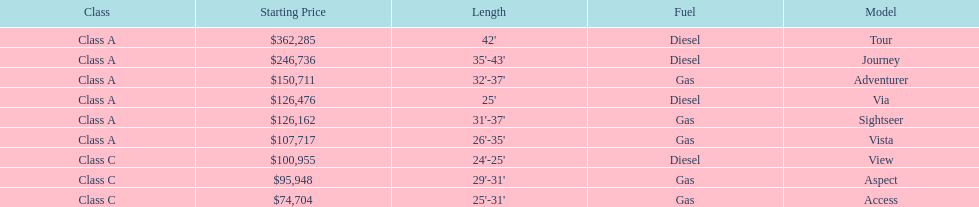Help me parse the entirety of this table. {'header': ['Class', 'Starting Price', 'Length', 'Fuel', 'Model'], 'rows': [['Class A', '$362,285', "42'", 'Diesel', 'Tour'], ['Class A', '$246,736', "35'-43'", 'Diesel', 'Journey'], ['Class A', '$150,711', "32'-37'", 'Gas', 'Adventurer'], ['Class A', '$126,476', "25'", 'Diesel', 'Via'], ['Class A', '$126,162', "31'-37'", 'Gas', 'Sightseer'], ['Class A', '$107,717', "26'-35'", 'Gas', 'Vista'], ['Class C', '$100,955', "24'-25'", 'Diesel', 'View'], ['Class C', '$95,948', "29'-31'", 'Gas', 'Aspect'], ['Class C', '$74,704', "25'-31'", 'Gas', 'Access']]} Which model is at the top of the list with the highest starting price? Tour. 